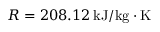<formula> <loc_0><loc_0><loc_500><loc_500>R = 2 0 8 . 1 2 \, k J / k g \cdot K</formula> 